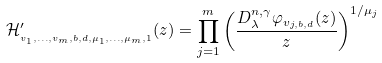<formula> <loc_0><loc_0><loc_500><loc_500>\mathcal { H } _ { _ { v _ { 1 } , \dots , v _ { m } , b , d , \mu _ { 1 } , \dots , \mu _ { m } , 1 } } ^ { \prime } ( z ) = \prod _ { j = 1 } ^ { m } \left ( \frac { D _ { \lambda } ^ { n , \gamma } \varphi _ { v _ { j , b , d } } ( z ) } { z } \right ) ^ { 1 / \mu _ { j } }</formula> 